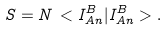Convert formula to latex. <formula><loc_0><loc_0><loc_500><loc_500>S = N \, < I ^ { B } _ { A n } | I ^ { B } _ { A n } > .</formula> 